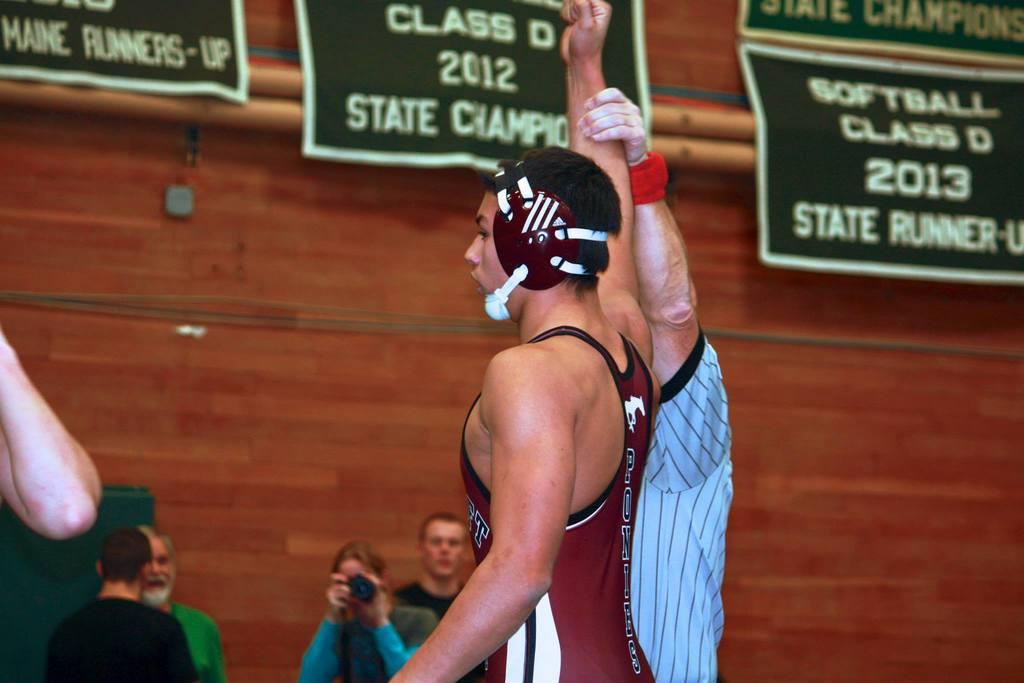What is the main subject in the foreground of the image? There is a boy standing in the foreground of the image. What is happening on the left side of the image? Someone is taking a picture on the left side of the image. What type of pipe is the lawyer using to stop the boy in the image? There is no lawyer, pipe, or indication of the boy being stopped in the image. 